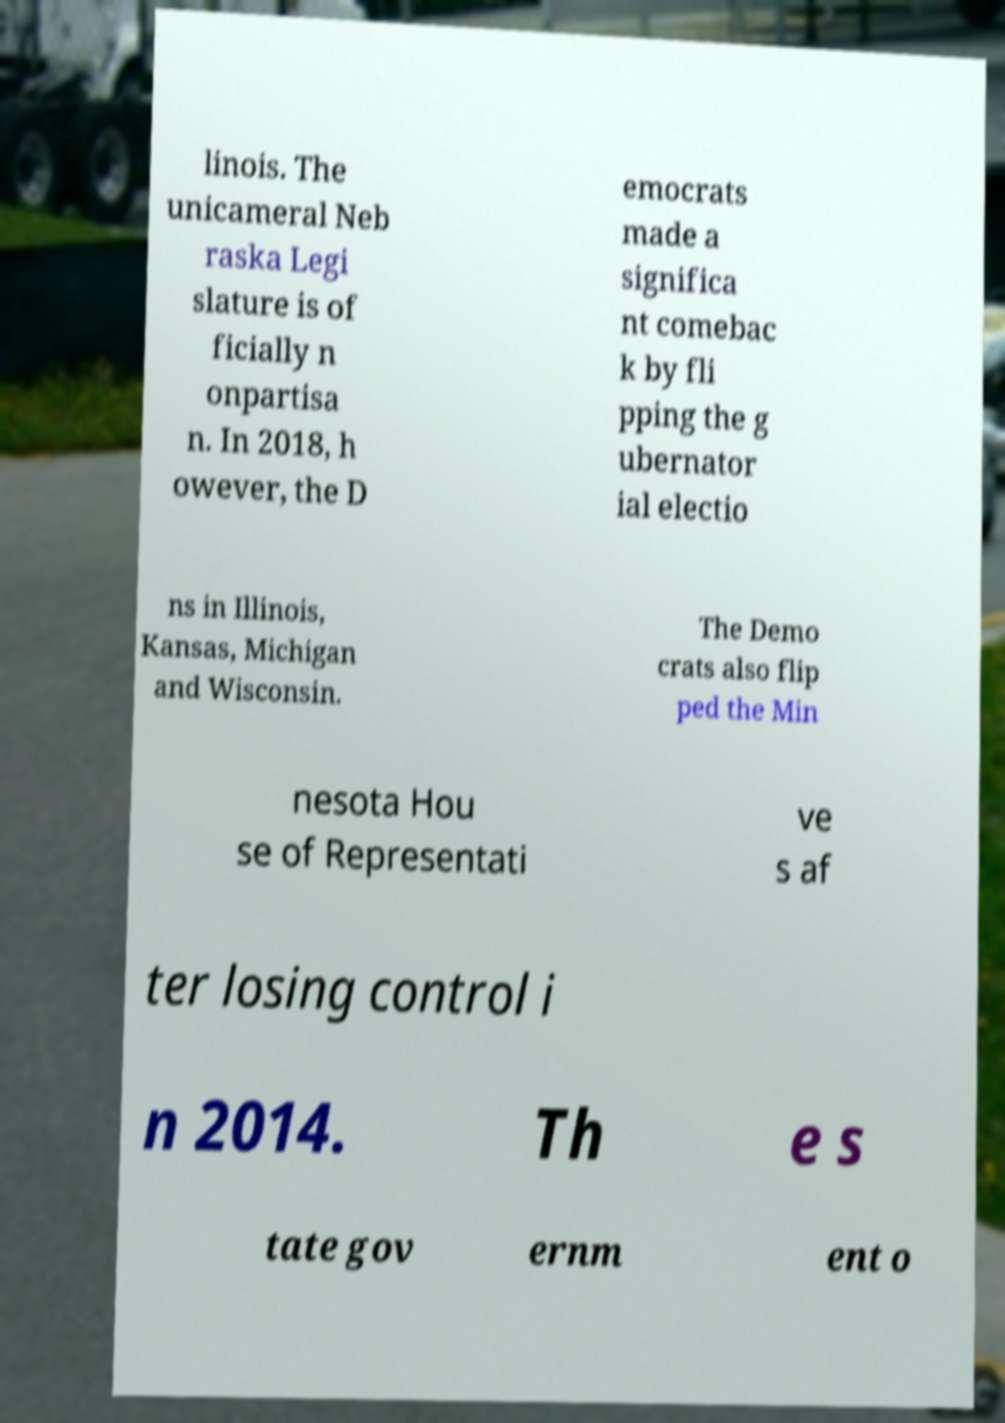For documentation purposes, I need the text within this image transcribed. Could you provide that? linois. The unicameral Neb raska Legi slature is of ficially n onpartisa n. In 2018, h owever, the D emocrats made a significa nt comebac k by fli pping the g ubernator ial electio ns in Illinois, Kansas, Michigan and Wisconsin. The Demo crats also flip ped the Min nesota Hou se of Representati ve s af ter losing control i n 2014. Th e s tate gov ernm ent o 